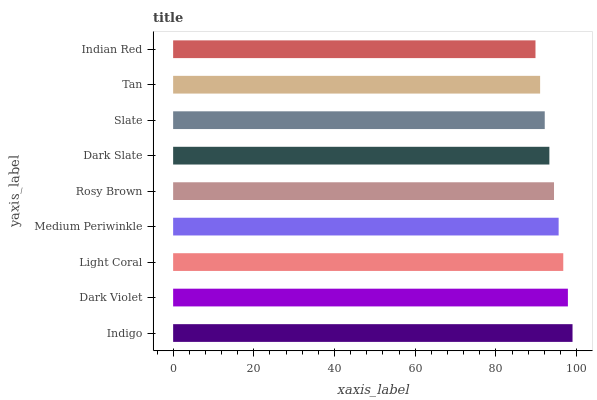Is Indian Red the minimum?
Answer yes or no. Yes. Is Indigo the maximum?
Answer yes or no. Yes. Is Dark Violet the minimum?
Answer yes or no. No. Is Dark Violet the maximum?
Answer yes or no. No. Is Indigo greater than Dark Violet?
Answer yes or no. Yes. Is Dark Violet less than Indigo?
Answer yes or no. Yes. Is Dark Violet greater than Indigo?
Answer yes or no. No. Is Indigo less than Dark Violet?
Answer yes or no. No. Is Rosy Brown the high median?
Answer yes or no. Yes. Is Rosy Brown the low median?
Answer yes or no. Yes. Is Tan the high median?
Answer yes or no. No. Is Medium Periwinkle the low median?
Answer yes or no. No. 